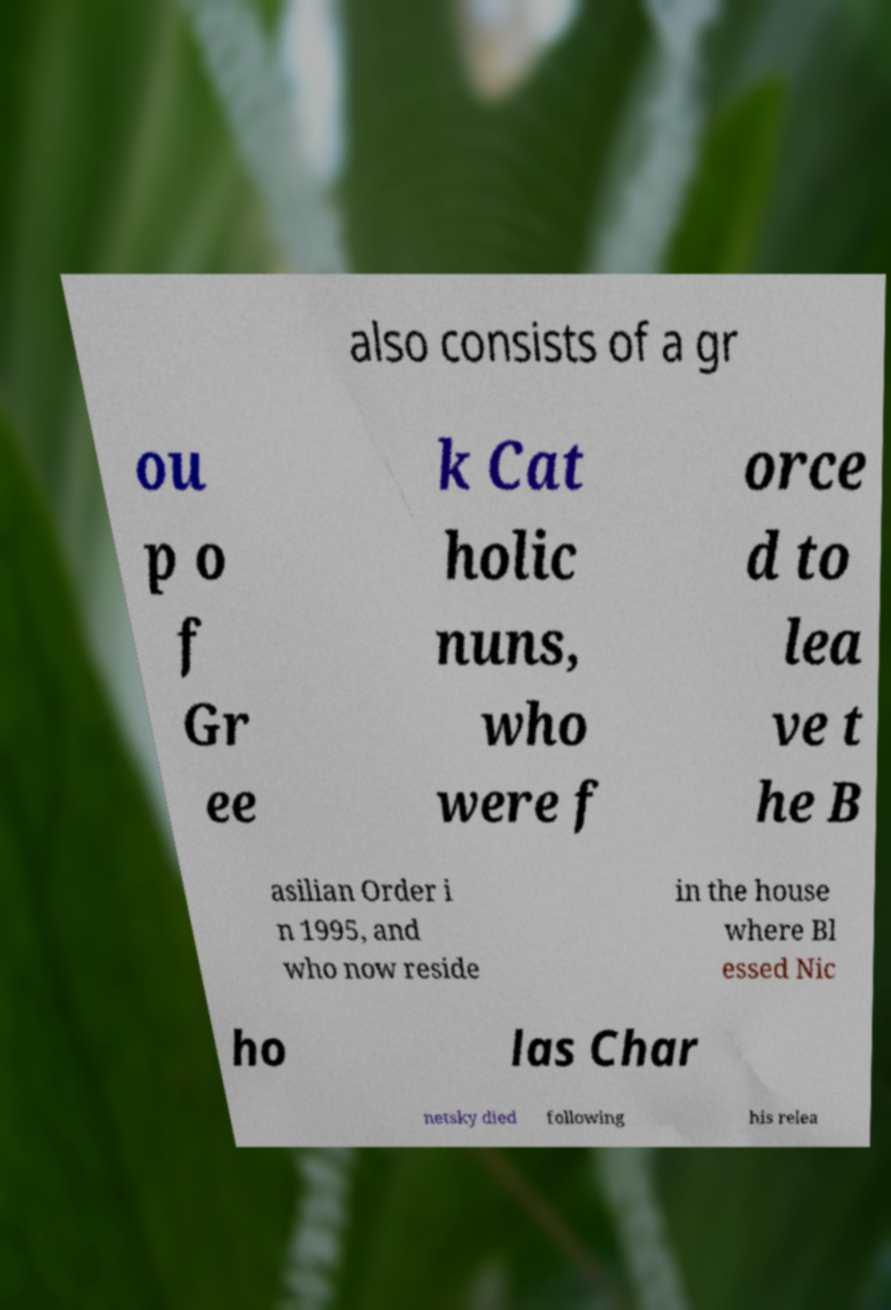There's text embedded in this image that I need extracted. Can you transcribe it verbatim? also consists of a gr ou p o f Gr ee k Cat holic nuns, who were f orce d to lea ve t he B asilian Order i n 1995, and who now reside in the house where Bl essed Nic ho las Char netsky died following his relea 